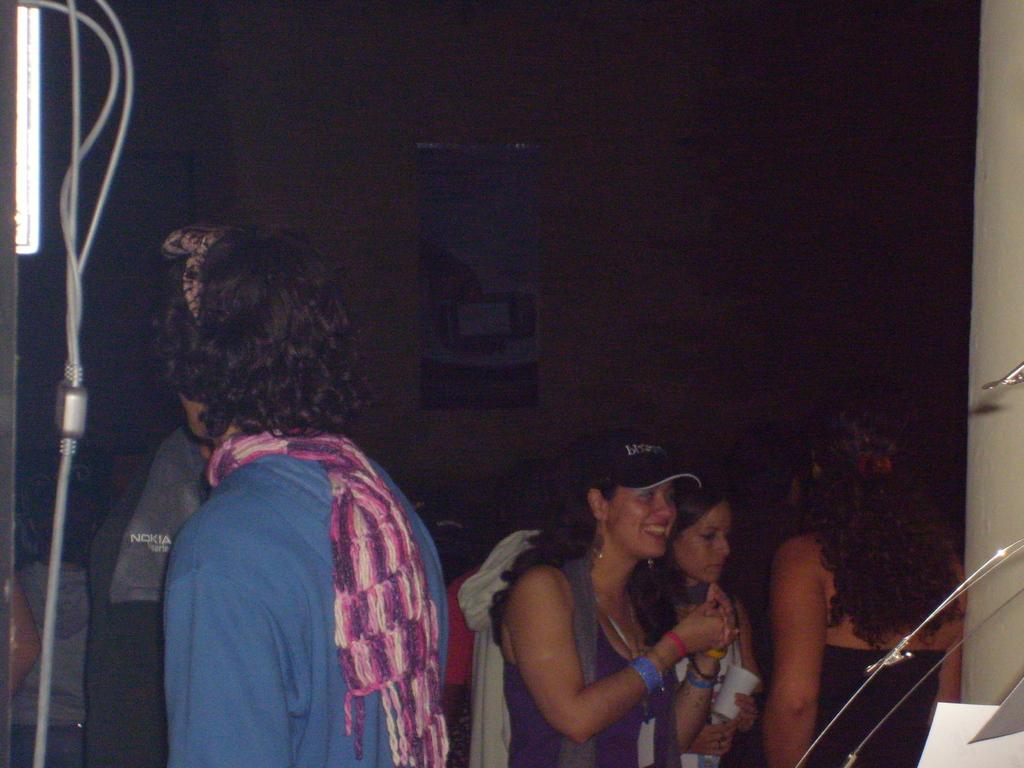What is happening in the center of the image? There are people standing in the center of the image. What can be seen in the background of the image? There is a wall in the background of the image. What type of fiction is being read by the people in the image? There is no indication of any reading material in the image, and therefore no fiction can be identified. Can you see any bats flying in the image? There are no bats present in the image. 